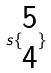<formula> <loc_0><loc_0><loc_500><loc_500>s \{ \begin{matrix} 5 \\ 4 \end{matrix} \}</formula> 